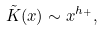Convert formula to latex. <formula><loc_0><loc_0><loc_500><loc_500>\tilde { K } ( x ) \sim x ^ { h _ { + } } ,</formula> 